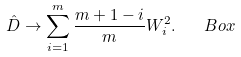Convert formula to latex. <formula><loc_0><loc_0><loc_500><loc_500>\hat { D } \rightarrow \sum ^ { m } _ { i = 1 } \frac { m + 1 - i } { m } W ^ { 2 } _ { i } . \quad B o x</formula> 